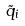<formula> <loc_0><loc_0><loc_500><loc_500>\tilde { q } _ { i }</formula> 